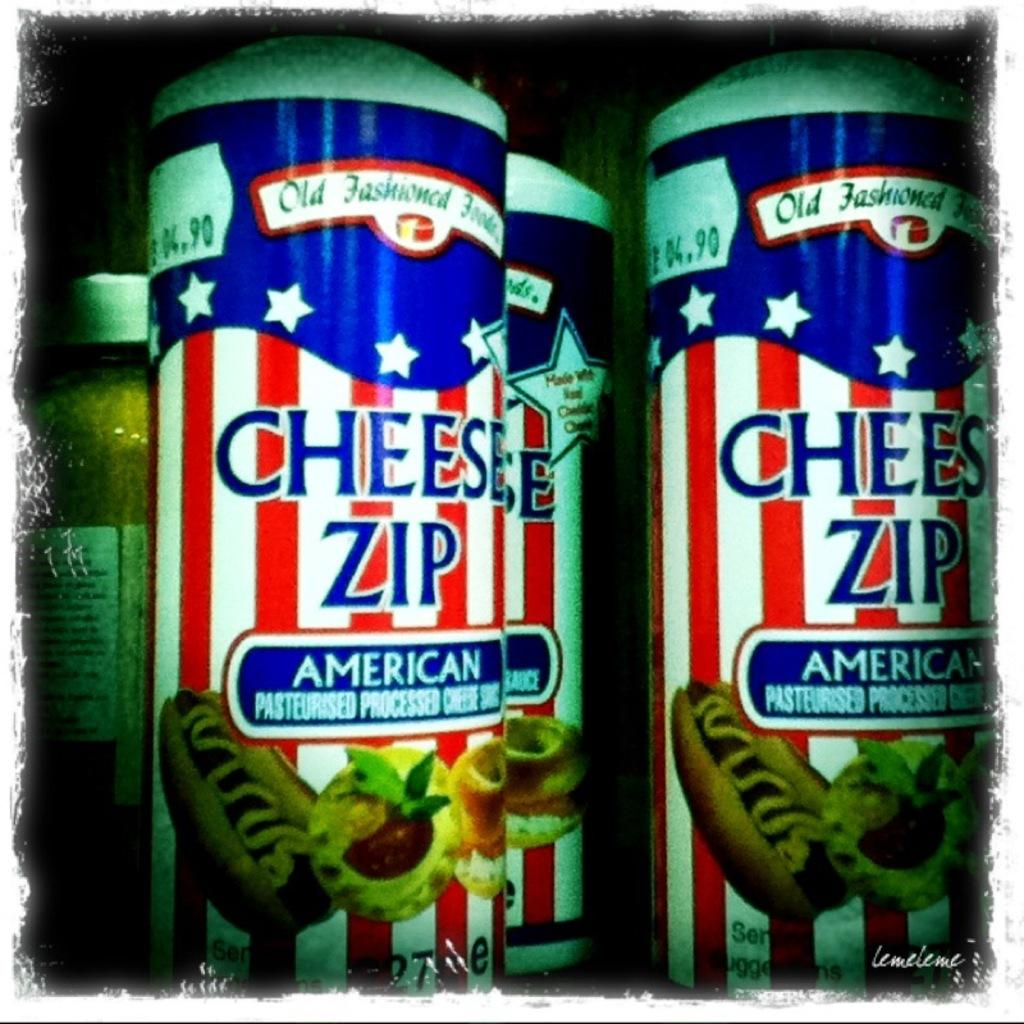<image>
Summarize the visual content of the image. Cans containing Cheese Zip processed cheese are displayed. 